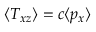Convert formula to latex. <formula><loc_0><loc_0><loc_500><loc_500>\langle T _ { x z } \rangle = c \langle p _ { x } \rangle</formula> 